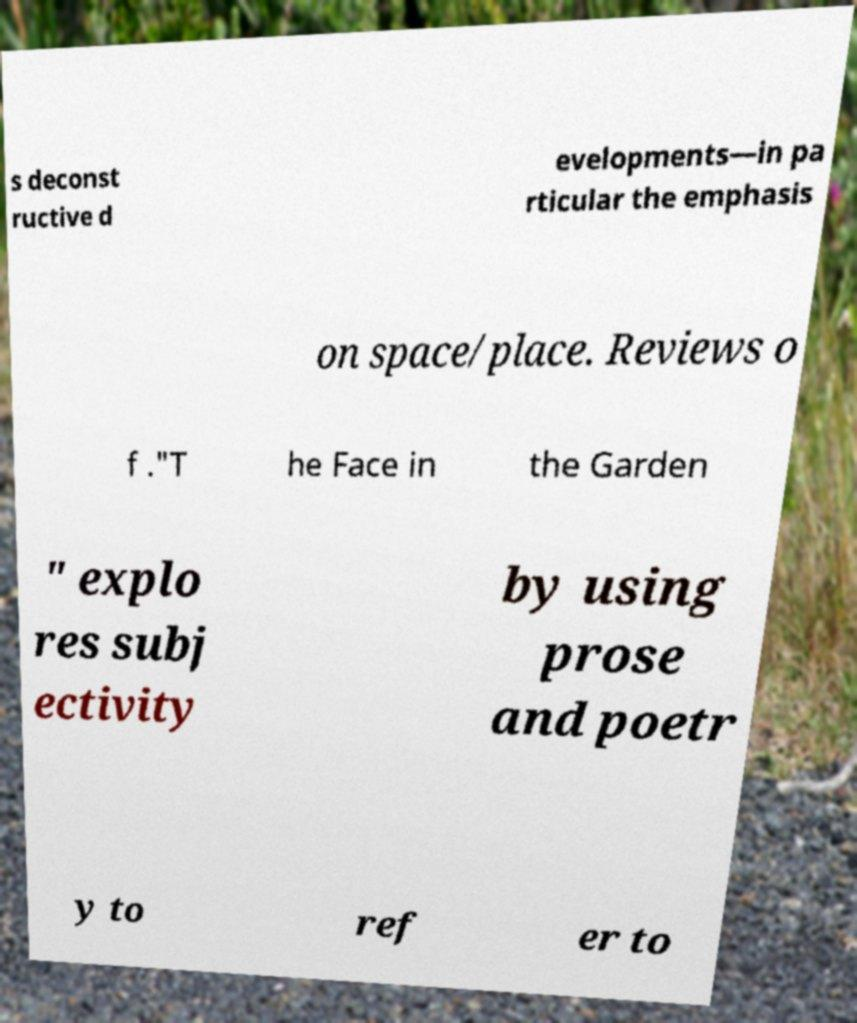Please identify and transcribe the text found in this image. s deconst ructive d evelopments—in pa rticular the emphasis on space/place. Reviews o f ."T he Face in the Garden " explo res subj ectivity by using prose and poetr y to ref er to 